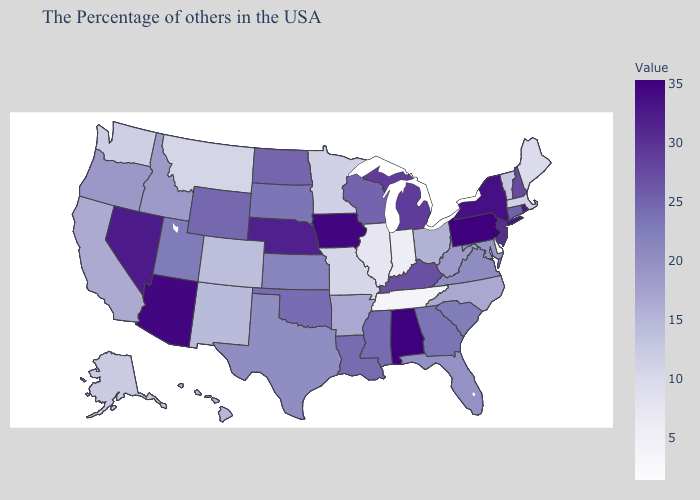Does South Dakota have the highest value in the USA?
Keep it brief. No. Does Oregon have the lowest value in the West?
Give a very brief answer. No. Among the states that border Montana , does Idaho have the lowest value?
Short answer required. Yes. Does the map have missing data?
Answer briefly. No. Does Oklahoma have a higher value than New Jersey?
Concise answer only. No. Is the legend a continuous bar?
Quick response, please. Yes. 